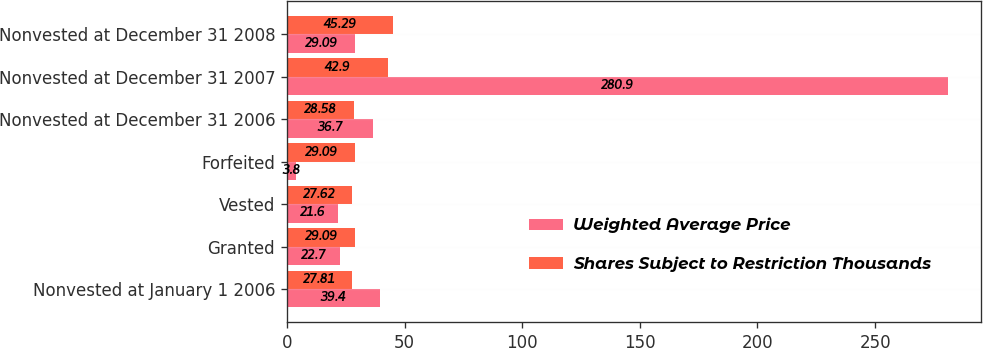Convert chart. <chart><loc_0><loc_0><loc_500><loc_500><stacked_bar_chart><ecel><fcel>Nonvested at January 1 2006<fcel>Granted<fcel>Vested<fcel>Forfeited<fcel>Nonvested at December 31 2006<fcel>Nonvested at December 31 2007<fcel>Nonvested at December 31 2008<nl><fcel>Weighted Average Price<fcel>39.4<fcel>22.7<fcel>21.6<fcel>3.8<fcel>36.7<fcel>280.9<fcel>29.09<nl><fcel>Shares Subject to Restriction Thousands<fcel>27.81<fcel>29.09<fcel>27.62<fcel>29.09<fcel>28.58<fcel>42.9<fcel>45.29<nl></chart> 